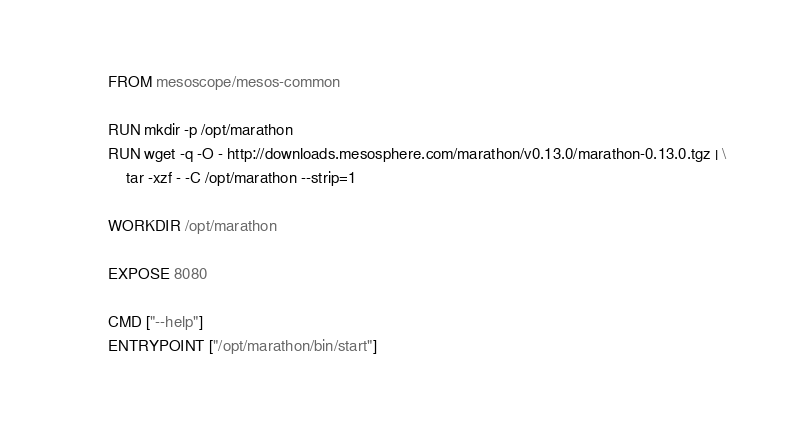Convert code to text. <code><loc_0><loc_0><loc_500><loc_500><_Dockerfile_>

FROM mesoscope/mesos-common

RUN mkdir -p /opt/marathon
RUN wget -q -O - http://downloads.mesosphere.com/marathon/v0.13.0/marathon-0.13.0.tgz | \
	tar -xzf - -C /opt/marathon --strip=1

WORKDIR /opt/marathon

EXPOSE 8080

CMD ["--help"]
ENTRYPOINT ["/opt/marathon/bin/start"]
</code> 